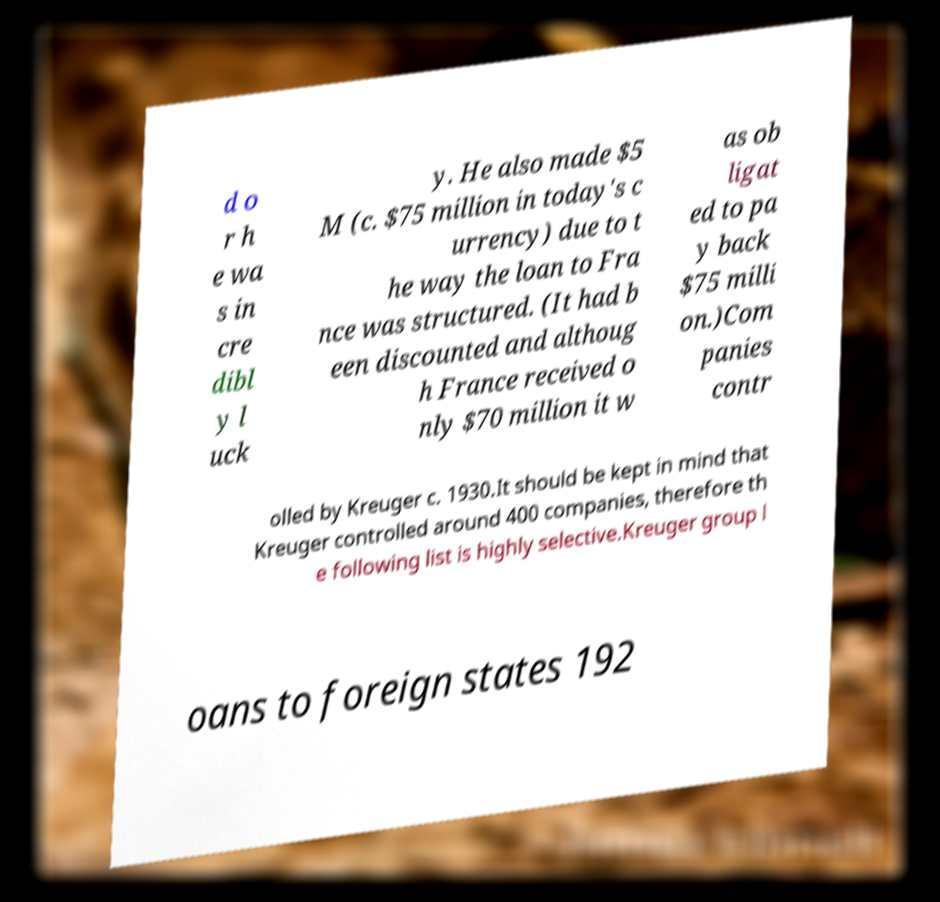What messages or text are displayed in this image? I need them in a readable, typed format. d o r h e wa s in cre dibl y l uck y. He also made $5 M (c. $75 million in today's c urrency) due to t he way the loan to Fra nce was structured. (It had b een discounted and althoug h France received o nly $70 million it w as ob ligat ed to pa y back $75 milli on.)Com panies contr olled by Kreuger c. 1930.It should be kept in mind that Kreuger controlled around 400 companies, therefore th e following list is highly selective.Kreuger group l oans to foreign states 192 